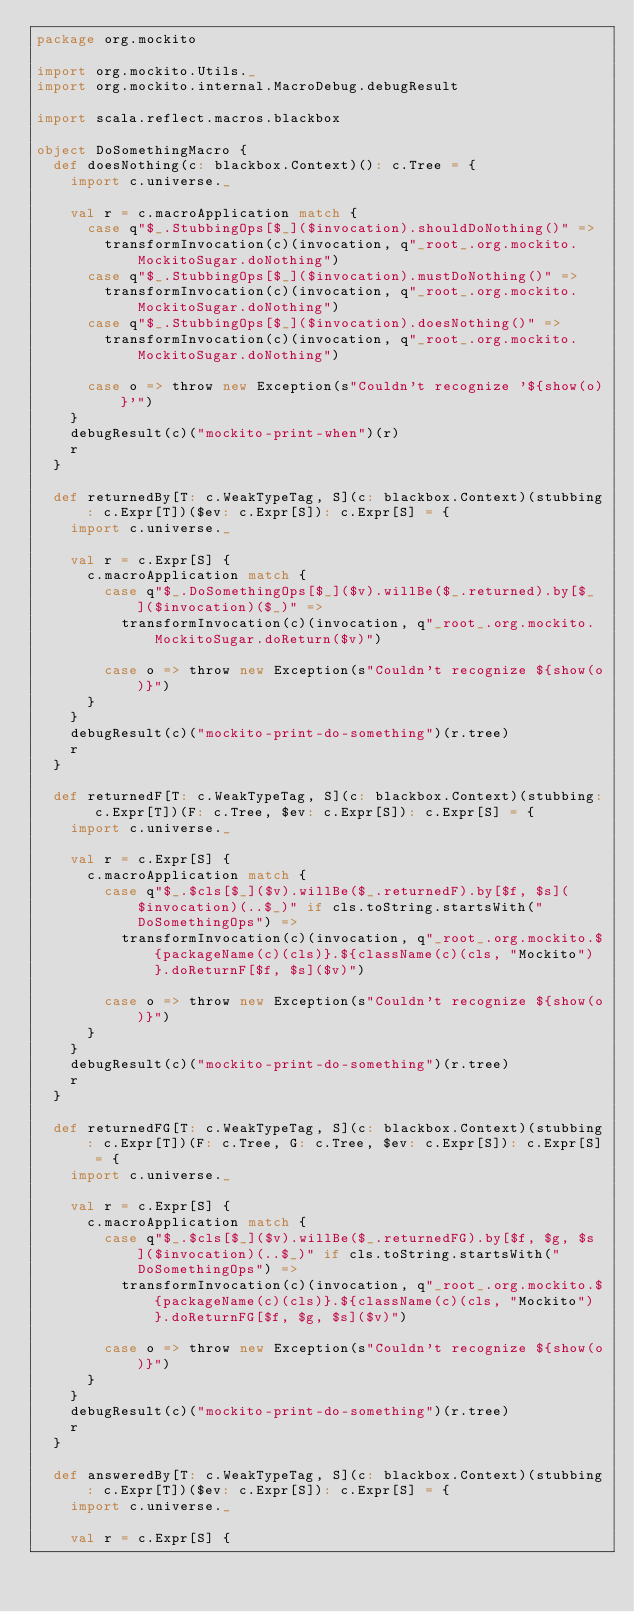Convert code to text. <code><loc_0><loc_0><loc_500><loc_500><_Scala_>package org.mockito

import org.mockito.Utils._
import org.mockito.internal.MacroDebug.debugResult

import scala.reflect.macros.blackbox

object DoSomethingMacro {
  def doesNothing(c: blackbox.Context)(): c.Tree = {
    import c.universe._

    val r = c.macroApplication match {
      case q"$_.StubbingOps[$_]($invocation).shouldDoNothing()" =>
        transformInvocation(c)(invocation, q"_root_.org.mockito.MockitoSugar.doNothing")
      case q"$_.StubbingOps[$_]($invocation).mustDoNothing()" =>
        transformInvocation(c)(invocation, q"_root_.org.mockito.MockitoSugar.doNothing")
      case q"$_.StubbingOps[$_]($invocation).doesNothing()" =>
        transformInvocation(c)(invocation, q"_root_.org.mockito.MockitoSugar.doNothing")

      case o => throw new Exception(s"Couldn't recognize '${show(o)}'")
    }
    debugResult(c)("mockito-print-when")(r)
    r
  }

  def returnedBy[T: c.WeakTypeTag, S](c: blackbox.Context)(stubbing: c.Expr[T])($ev: c.Expr[S]): c.Expr[S] = {
    import c.universe._

    val r = c.Expr[S] {
      c.macroApplication match {
        case q"$_.DoSomethingOps[$_]($v).willBe($_.returned).by[$_]($invocation)($_)" =>
          transformInvocation(c)(invocation, q"_root_.org.mockito.MockitoSugar.doReturn($v)")

        case o => throw new Exception(s"Couldn't recognize ${show(o)}")
      }
    }
    debugResult(c)("mockito-print-do-something")(r.tree)
    r
  }

  def returnedF[T: c.WeakTypeTag, S](c: blackbox.Context)(stubbing: c.Expr[T])(F: c.Tree, $ev: c.Expr[S]): c.Expr[S] = {
    import c.universe._

    val r = c.Expr[S] {
      c.macroApplication match {
        case q"$_.$cls[$_]($v).willBe($_.returnedF).by[$f, $s]($invocation)(..$_)" if cls.toString.startsWith("DoSomethingOps") =>
          transformInvocation(c)(invocation, q"_root_.org.mockito.${packageName(c)(cls)}.${className(c)(cls, "Mockito")}.doReturnF[$f, $s]($v)")

        case o => throw new Exception(s"Couldn't recognize ${show(o)}")
      }
    }
    debugResult(c)("mockito-print-do-something")(r.tree)
    r
  }

  def returnedFG[T: c.WeakTypeTag, S](c: blackbox.Context)(stubbing: c.Expr[T])(F: c.Tree, G: c.Tree, $ev: c.Expr[S]): c.Expr[S] = {
    import c.universe._

    val r = c.Expr[S] {
      c.macroApplication match {
        case q"$_.$cls[$_]($v).willBe($_.returnedFG).by[$f, $g, $s]($invocation)(..$_)" if cls.toString.startsWith("DoSomethingOps") =>
          transformInvocation(c)(invocation, q"_root_.org.mockito.${packageName(c)(cls)}.${className(c)(cls, "Mockito")}.doReturnFG[$f, $g, $s]($v)")

        case o => throw new Exception(s"Couldn't recognize ${show(o)}")
      }
    }
    debugResult(c)("mockito-print-do-something")(r.tree)
    r
  }

  def answeredBy[T: c.WeakTypeTag, S](c: blackbox.Context)(stubbing: c.Expr[T])($ev: c.Expr[S]): c.Expr[S] = {
    import c.universe._

    val r = c.Expr[S] {</code> 